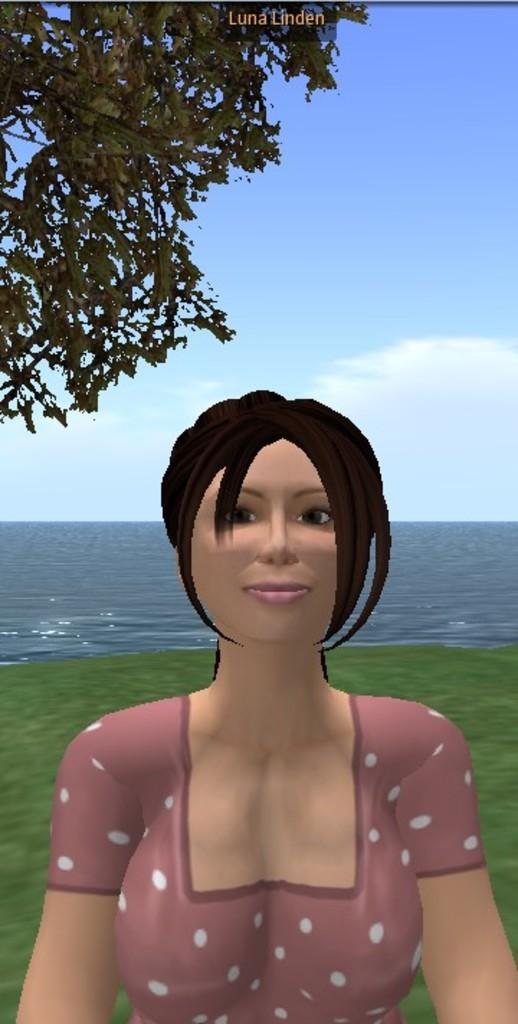What type of image is present in the picture? There is an animated image of a person in the picture. What type of natural environment is visible in the image? There is grass and water visible in the image. What is visible at the top of the image? The sky is visible at the top of the image. What type of vegetation is present in the image? Leaves are present in the image. Is there any text in the image? Yes, there is some text in the image. What type of needle is being used to sew a shop in the image? There is no needle, shop, or sewing activity present in the image. 